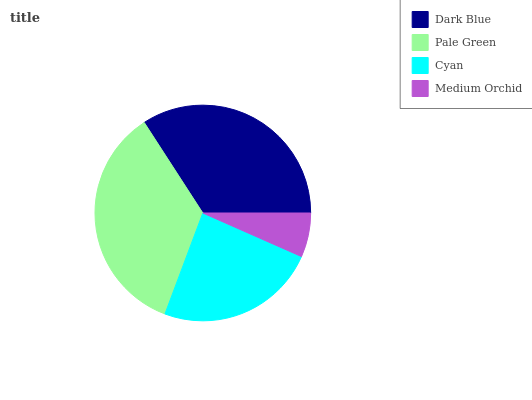Is Medium Orchid the minimum?
Answer yes or no. Yes. Is Pale Green the maximum?
Answer yes or no. Yes. Is Cyan the minimum?
Answer yes or no. No. Is Cyan the maximum?
Answer yes or no. No. Is Pale Green greater than Cyan?
Answer yes or no. Yes. Is Cyan less than Pale Green?
Answer yes or no. Yes. Is Cyan greater than Pale Green?
Answer yes or no. No. Is Pale Green less than Cyan?
Answer yes or no. No. Is Dark Blue the high median?
Answer yes or no. Yes. Is Cyan the low median?
Answer yes or no. Yes. Is Pale Green the high median?
Answer yes or no. No. Is Pale Green the low median?
Answer yes or no. No. 